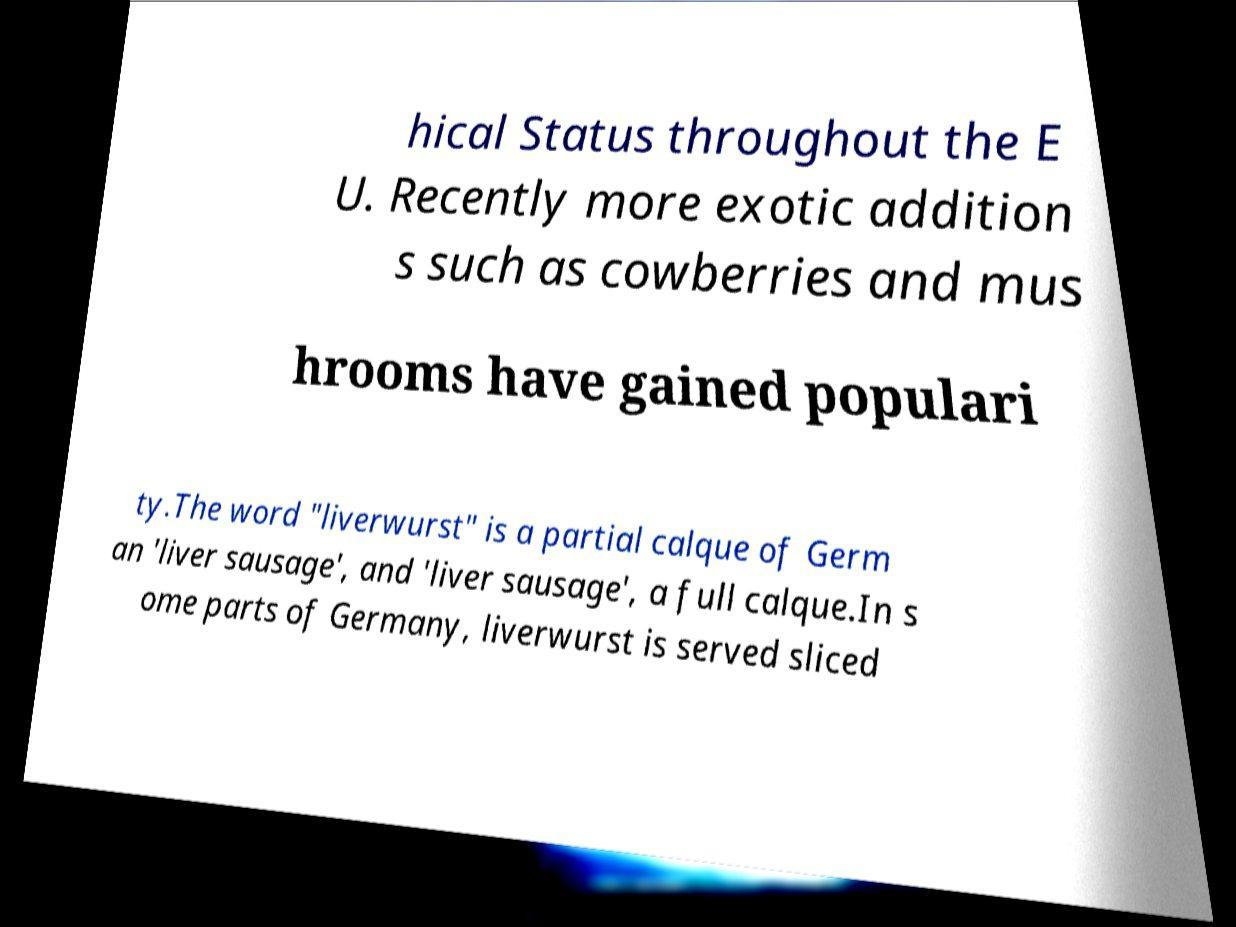Could you extract and type out the text from this image? hical Status throughout the E U. Recently more exotic addition s such as cowberries and mus hrooms have gained populari ty.The word "liverwurst" is a partial calque of Germ an 'liver sausage', and 'liver sausage', a full calque.In s ome parts of Germany, liverwurst is served sliced 